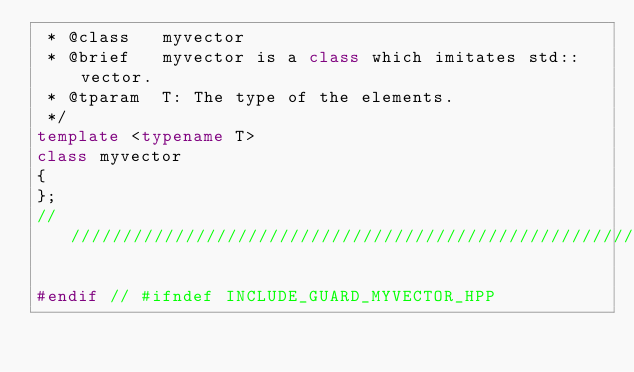Convert code to text. <code><loc_0><loc_0><loc_500><loc_500><_C++_> * @class   myvector
 * @brief   myvector is a class which imitates std::vector.
 * @tparam  T: The type of the elements.
 */
template <typename T>
class myvector
{
};
/////////////////////////////////////////////////////////////////////////////

#endif // #ifndef INCLUDE_GUARD_MYVECTOR_HPP
</code> 